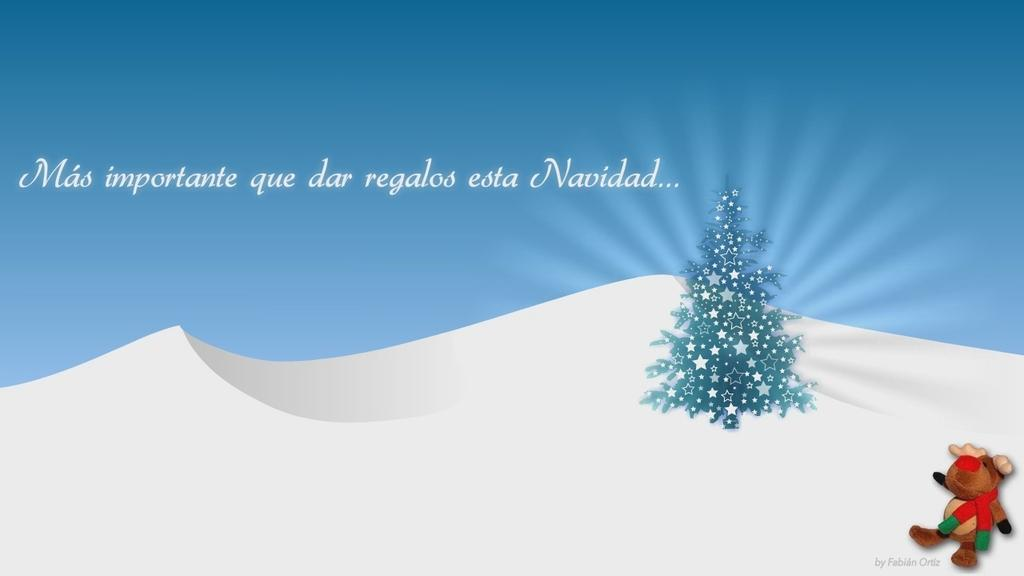What type of image is being described? The image is an animation. What is one of the main objects in the image? There is an xmas tree in the image. What other object can be seen in the image? There is a soft toy in the image. Are there any words or letters in the image? Yes, there is text in the image. What type of landscape is visible in the image? There are hills visible in the image. How many times does the key twist in the image? There is no key present in the image, so it cannot be determined how many times it would twist. 